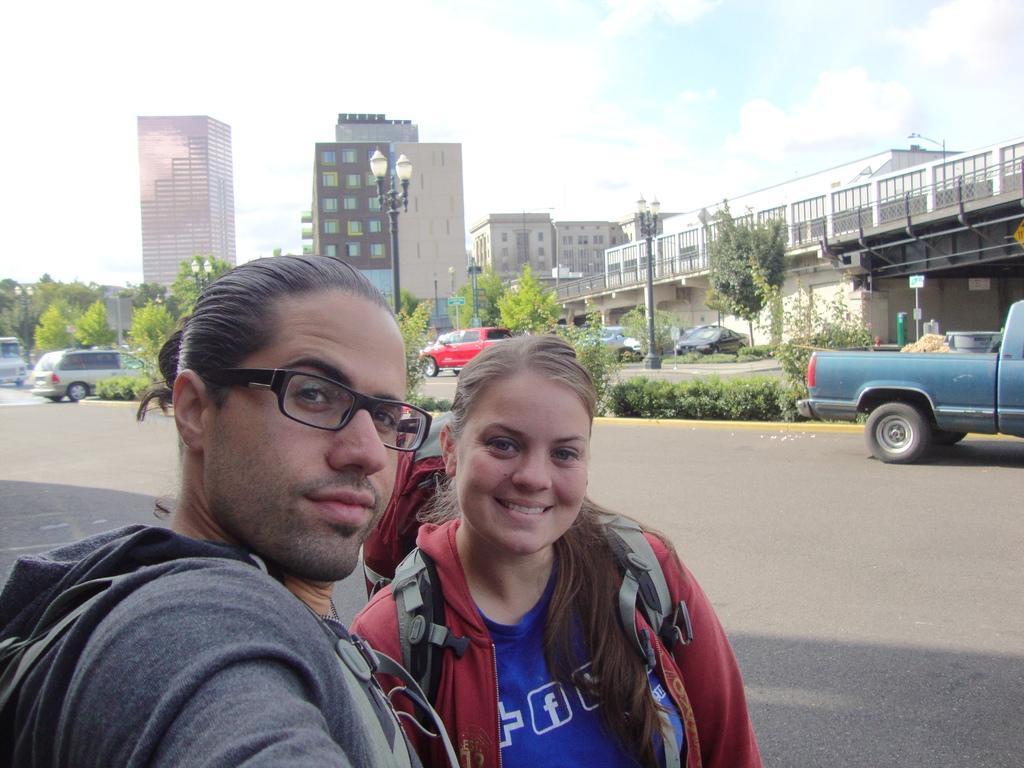Can you describe this image briefly? In this image we can see two people, a lady is wearing a backpack, behind them there are some vehicles, plants, trees, light poles, there is a bridge, buildings, also we can see the sky. 